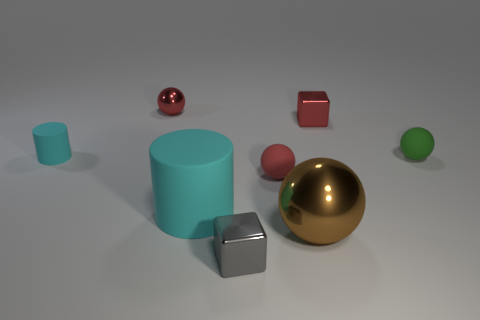Is there a brown thing that has the same material as the gray block?
Your answer should be compact. Yes. Is the size of the block that is to the right of the gray shiny block the same as the large matte cylinder?
Your answer should be very brief. No. There is a tiny matte object to the left of the red ball that is to the left of the gray metallic cube; are there any red matte balls behind it?
Your response must be concise. No. How many rubber things are either large brown cylinders or gray objects?
Make the answer very short. 0. What number of other objects are there of the same shape as the large brown object?
Offer a very short reply. 3. Is the number of large gray matte blocks greater than the number of large cylinders?
Provide a short and direct response. No. What size is the red object right of the metallic ball that is in front of the red shiny object right of the gray block?
Your answer should be compact. Small. What size is the red sphere to the right of the small gray metallic object?
Make the answer very short. Small. How many objects are blocks or metal things right of the tiny gray shiny block?
Offer a very short reply. 3. How many other things are there of the same size as the red matte ball?
Your answer should be very brief. 5. 